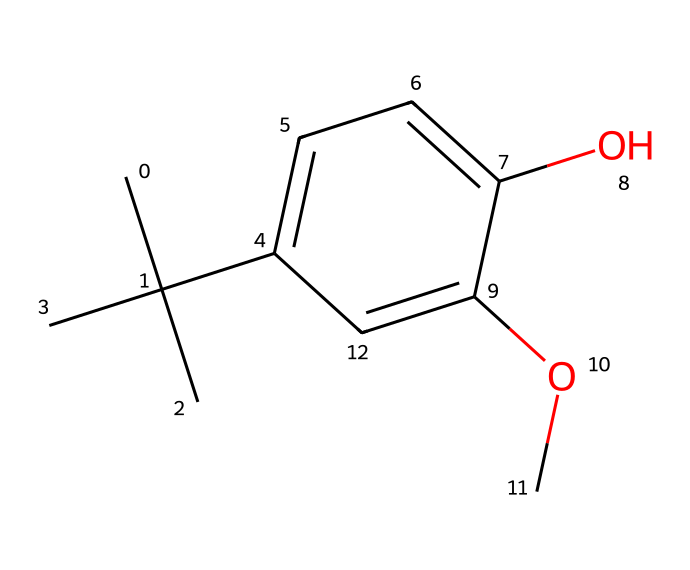What is the name of this chemical? The provided SMILES structure corresponds to butylated hydroxyanisole (BHA), which is an antioxidant commonly used in food and cosmetics for preservation.
Answer: butylated hydroxyanisole How many carbon atoms are present in this structure? By analyzing the structure, we can count the total number of carbon atoms represented in the SMILES. There are 12 carbon atoms in the structure of BHA.
Answer: 12 What functional groups are present in this molecule? The functional groups can be identified by looking for -OH (hydroxyl) groups and -OCH3 (methoxy) groups. The structure shows one hydroxyl group and one methoxy group.
Answer: hydroxyl and methoxy How many aromatic rings are in this structure? Observing the compound, we can identify that there is one aromatic ring present, indicated by the cyclic arrangement of carbon atoms and alternating double bonds.
Answer: 1 What is the molecular formula of butylated hydroxyanisole? To determine the molecular formula, we analyze the number of carbon, hydrogen, and oxygen atoms present, leading to the formula C12H16O2.
Answer: C12H16O2 Which part of this chemical contributes to its antioxidant properties? The hydroxyl group (-OH) attached to the aromatic ring is primarily responsible for the antioxidant properties, as it can donate hydrogen to free radicals, neutralizing them.
Answer: hydroxyl group What does the presence of electron-donating groups suggest about this compound's stability? The presence of electron-donating groups, like the methoxy group, suggests increased stability of the radical formed during antioxidant action, as it can stabilize the positive charge through resonance.
Answer: increased stability 